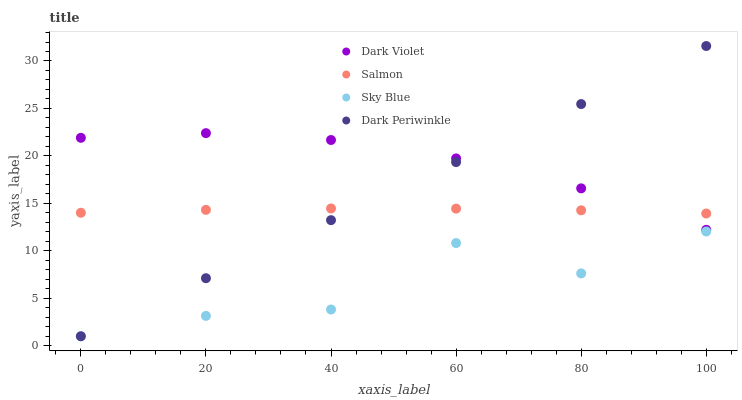Does Sky Blue have the minimum area under the curve?
Answer yes or no. Yes. Does Dark Violet have the maximum area under the curve?
Answer yes or no. Yes. Does Salmon have the minimum area under the curve?
Answer yes or no. No. Does Salmon have the maximum area under the curve?
Answer yes or no. No. Is Dark Periwinkle the smoothest?
Answer yes or no. Yes. Is Sky Blue the roughest?
Answer yes or no. Yes. Is Salmon the smoothest?
Answer yes or no. No. Is Salmon the roughest?
Answer yes or no. No. Does Sky Blue have the lowest value?
Answer yes or no. Yes. Does Salmon have the lowest value?
Answer yes or no. No. Does Dark Periwinkle have the highest value?
Answer yes or no. Yes. Does Salmon have the highest value?
Answer yes or no. No. Is Sky Blue less than Dark Violet?
Answer yes or no. Yes. Is Salmon greater than Sky Blue?
Answer yes or no. Yes. Does Dark Periwinkle intersect Sky Blue?
Answer yes or no. Yes. Is Dark Periwinkle less than Sky Blue?
Answer yes or no. No. Is Dark Periwinkle greater than Sky Blue?
Answer yes or no. No. Does Sky Blue intersect Dark Violet?
Answer yes or no. No. 